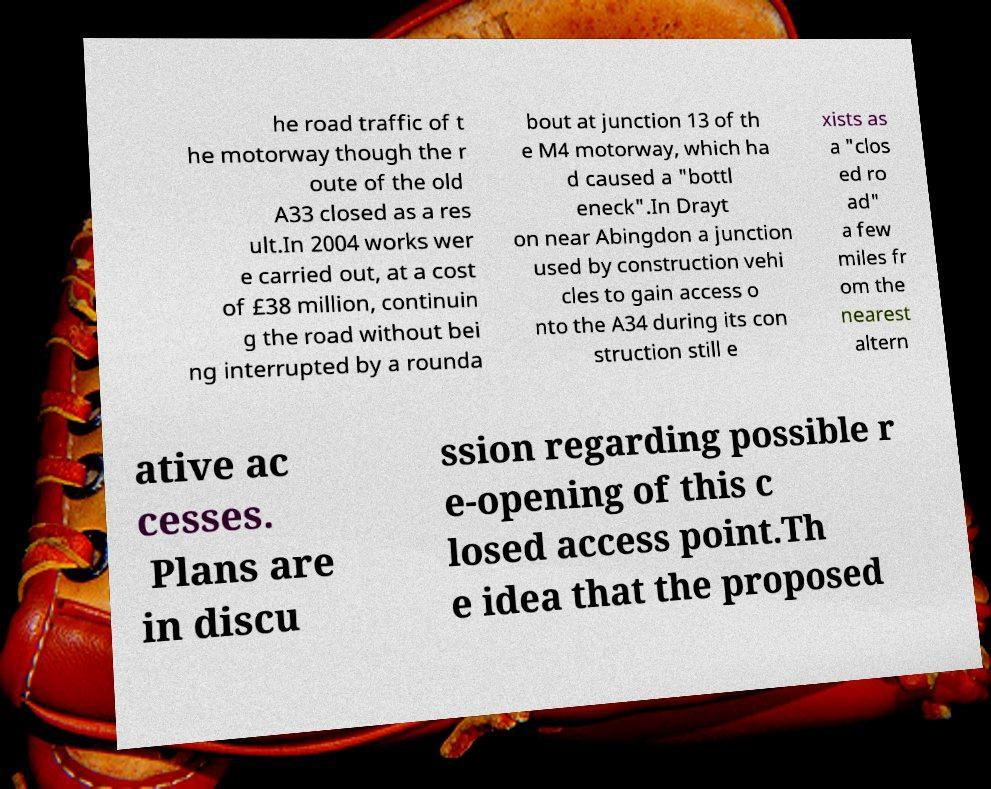Can you accurately transcribe the text from the provided image for me? he road traffic of t he motorway though the r oute of the old A33 closed as a res ult.In 2004 works wer e carried out, at a cost of £38 million, continuin g the road without bei ng interrupted by a rounda bout at junction 13 of th e M4 motorway, which ha d caused a "bottl eneck".In Drayt on near Abingdon a junction used by construction vehi cles to gain access o nto the A34 during its con struction still e xists as a "clos ed ro ad" a few miles fr om the nearest altern ative ac cesses. Plans are in discu ssion regarding possible r e-opening of this c losed access point.Th e idea that the proposed 